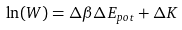<formula> <loc_0><loc_0><loc_500><loc_500>\ln ( W ) = \Delta \beta \Delta E _ { p o t } + \Delta K</formula> 